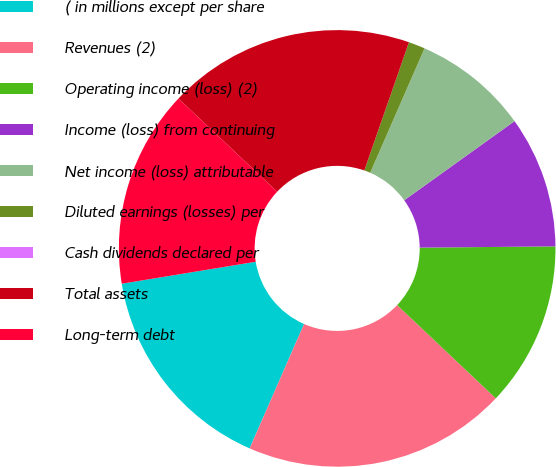<chart> <loc_0><loc_0><loc_500><loc_500><pie_chart><fcel>( in millions except per share<fcel>Revenues (2)<fcel>Operating income (loss) (2)<fcel>Income (loss) from continuing<fcel>Net income (loss) attributable<fcel>Diluted earnings (losses) per<fcel>Cash dividends declared per<fcel>Total assets<fcel>Long-term debt<nl><fcel>15.85%<fcel>19.51%<fcel>12.2%<fcel>9.76%<fcel>8.54%<fcel>1.22%<fcel>0.0%<fcel>18.29%<fcel>14.63%<nl></chart> 